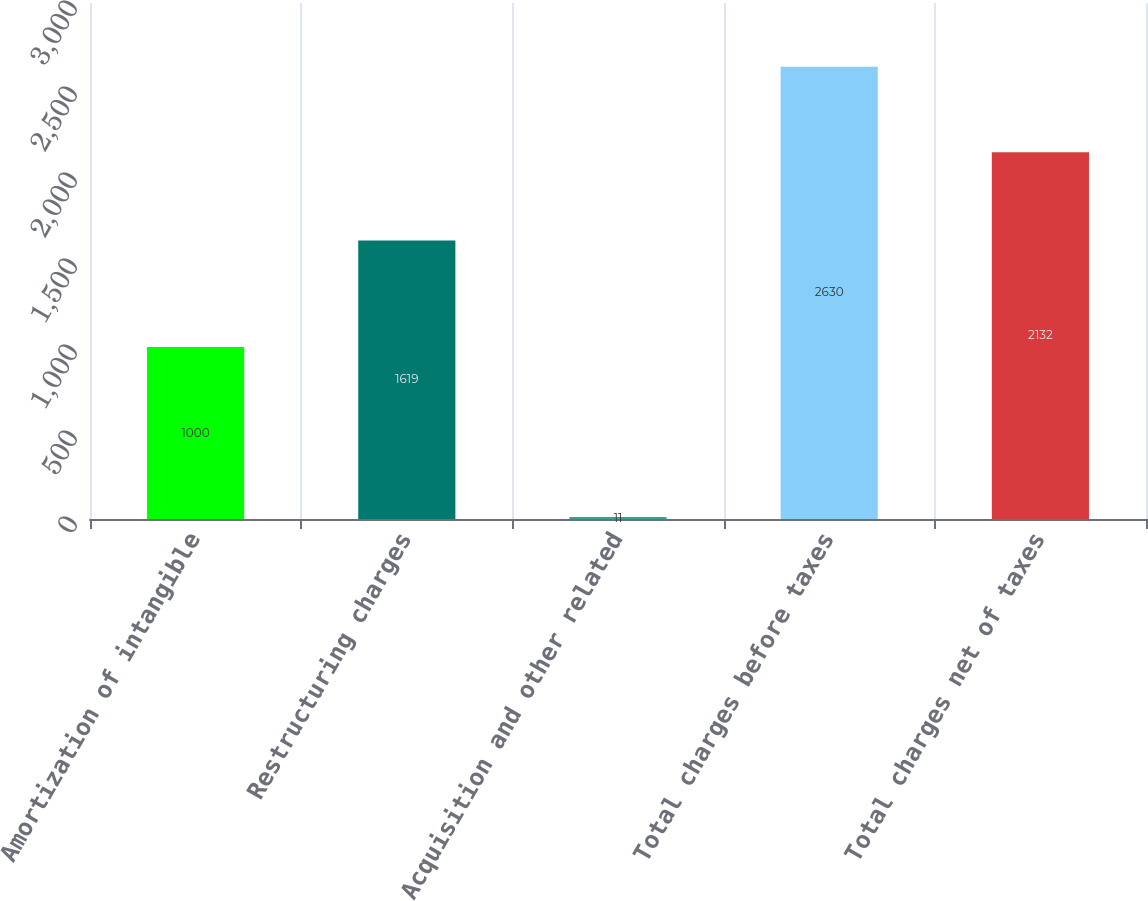Convert chart. <chart><loc_0><loc_0><loc_500><loc_500><bar_chart><fcel>Amortization of intangible<fcel>Restructuring charges<fcel>Acquisition and other related<fcel>Total charges before taxes<fcel>Total charges net of taxes<nl><fcel>1000<fcel>1619<fcel>11<fcel>2630<fcel>2132<nl></chart> 